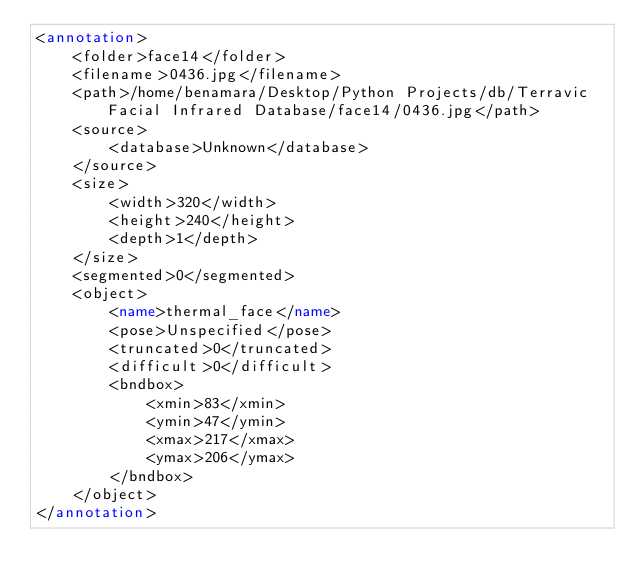Convert code to text. <code><loc_0><loc_0><loc_500><loc_500><_XML_><annotation>
	<folder>face14</folder>
	<filename>0436.jpg</filename>
	<path>/home/benamara/Desktop/Python Projects/db/Terravic Facial Infrared Database/face14/0436.jpg</path>
	<source>
		<database>Unknown</database>
	</source>
	<size>
		<width>320</width>
		<height>240</height>
		<depth>1</depth>
	</size>
	<segmented>0</segmented>
	<object>
		<name>thermal_face</name>
		<pose>Unspecified</pose>
		<truncated>0</truncated>
		<difficult>0</difficult>
		<bndbox>
			<xmin>83</xmin>
			<ymin>47</ymin>
			<xmax>217</xmax>
			<ymax>206</ymax>
		</bndbox>
	</object>
</annotation>
</code> 